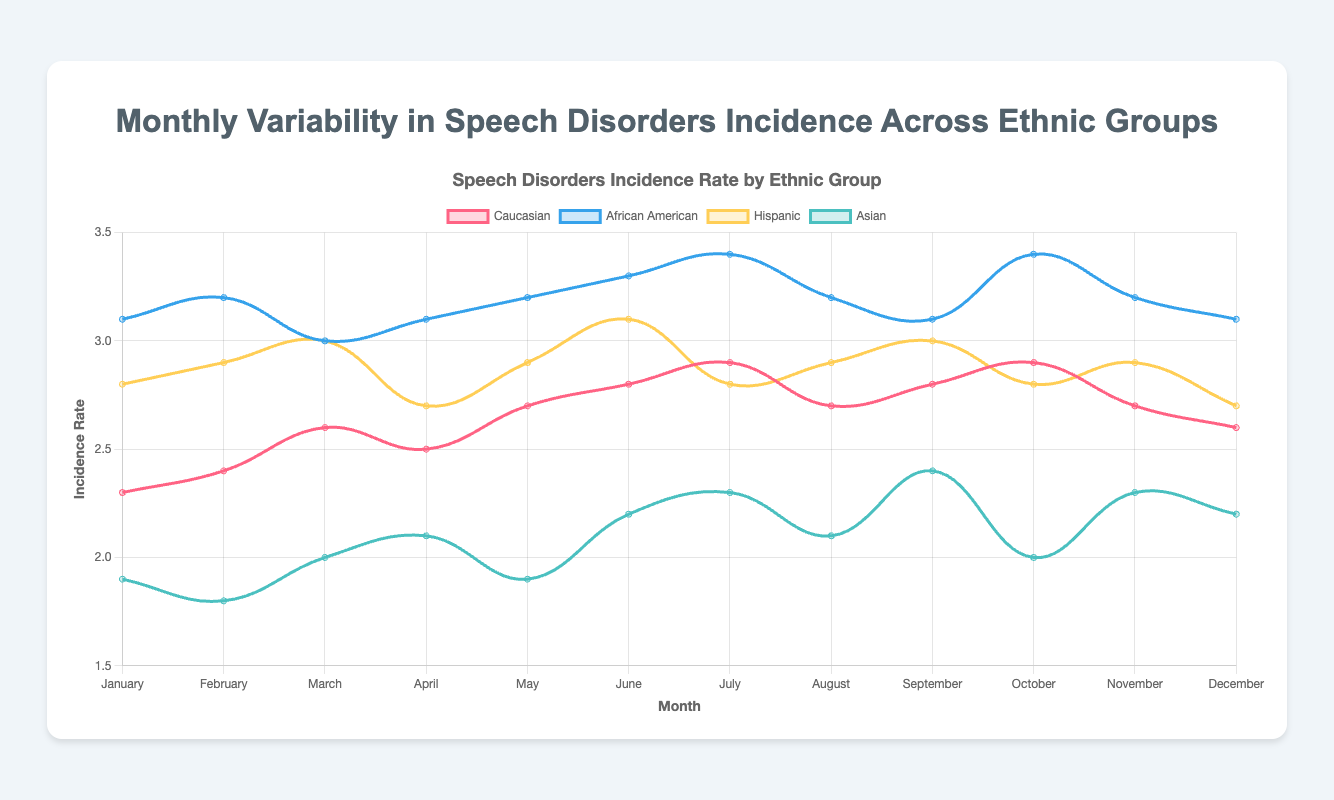What is the overall trend for the incidence rate of speech disorders in the "Caucasian" group from January to December? The line representing the "Caucasian" group shows an overall increasing trend in the incidence rate of speech disorders, with some fluctuations. The rate starts at 2.3 in January and peaks at 2.9 in October and then slightly decreases to 2.6 in December.
Answer: Increasing with fluctuations Which month has the highest incidence rate for "African American" population? By inspecting the figure, we see that the highest incidence rate for "African American" group occurs in July and October, both at a rate of 3.4.
Answer: July and October In which month do the "Asian" and "Caucasian" groups have equal incidence rates? The figure shows that in March, the incidence rates for both the "Asian" and "Caucasian" groups are equal at 2.0 and 2.6 respectively.
Answer: March What is the average incidence rate of speech disorders for the "Hispanic" group across the entire year? To calculate the average incidence rate, sum the incidence rates from January to December and divide by 12: (2.8 + 2.9 + 3.0 + 2.7 + 2.9 + 3.1 + 2.8 + 2.9 + 3.0 + 2.8 + 2.9 + 2.7)/12 = 34.5/12 = 2.875.
Answer: 2.88 How does the incidence rate for the "Asian" group in January compare to their rate in December? Comparing the plotted points, the rate for "Asian" group is higher in December (2.2) than in January (1.9).
Answer: Higher in December Which ethnic group shows the least variability in incidence rates across the year? By examining the fluctuation ranges of incidence rates on the graph, the "Asian" group shows the least variability, with rates ranging only from 1.8 to 2.4.
Answer: Asian Between which months does the "Hispanic" group see the greatest increase in incidence rate? The "Hispanic" group shows the greatest increase between March (3.0) and April (2.7), indicating a decrease rather than an increase. The correct period with the greatest increase is actually between February and March (2.9 to 3.0).
Answer: February to March What is the sum of incidence rates for "Caucasian" and "Asian" groups in June? Adding the incidence rates in June for the two groups: "Caucasian" (2.8) and "Asian" (2.2) gives a total of 2.8 + 2.2 = 5.0.
Answer: 5.0 Which group has the highest average incidence rate over the year? Calculate the average incidence rate for each group by summing their monthly rates and dividing by 12. "African American" shows the highest average with: (3.1 + 3.2 + 3.0 + 3.1 + 3.2 + 3.3 + 3.4 + 3.2 + 3.1 + 3.4 + 3.2 + 3.1)/12 = 37.5/12 = 3.125.
Answer: African American 